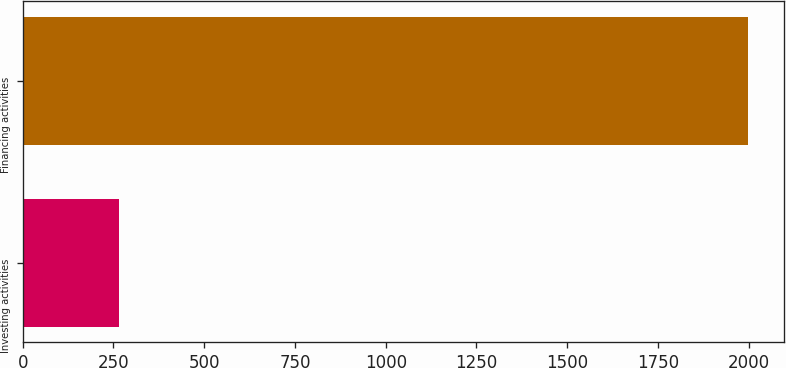Convert chart. <chart><loc_0><loc_0><loc_500><loc_500><bar_chart><fcel>Investing activities<fcel>Financing activities<nl><fcel>266<fcel>1997<nl></chart> 